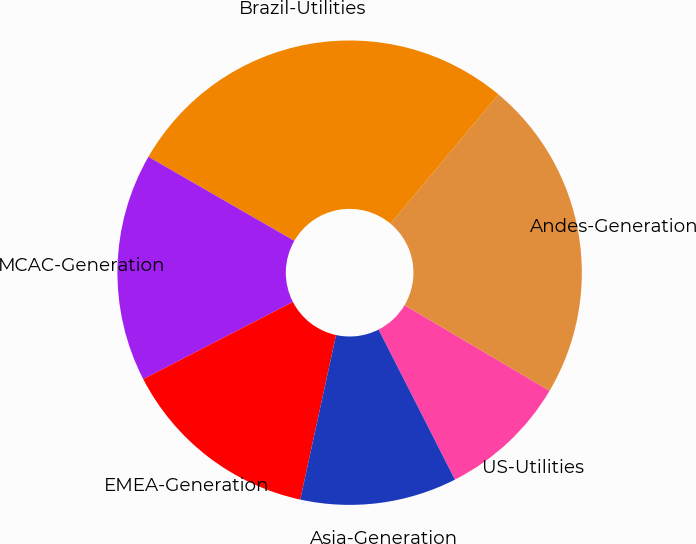Convert chart. <chart><loc_0><loc_0><loc_500><loc_500><pie_chart><fcel>US-Utilities<fcel>Andes-Generation<fcel>Brazil-Utilities<fcel>MCAC-Generation<fcel>EMEA-Generation<fcel>Asia-Generation<nl><fcel>9.02%<fcel>22.42%<fcel>27.75%<fcel>15.89%<fcel>14.01%<fcel>10.9%<nl></chart> 